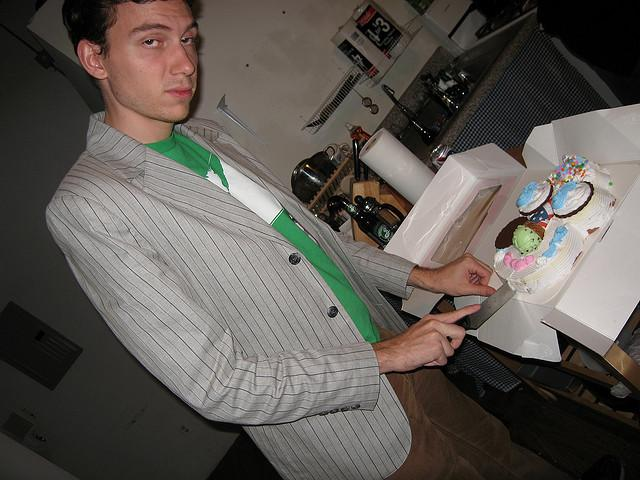What is inside the cake being cut? Please explain your reasoning. ice cream. The cake has ice cream. 